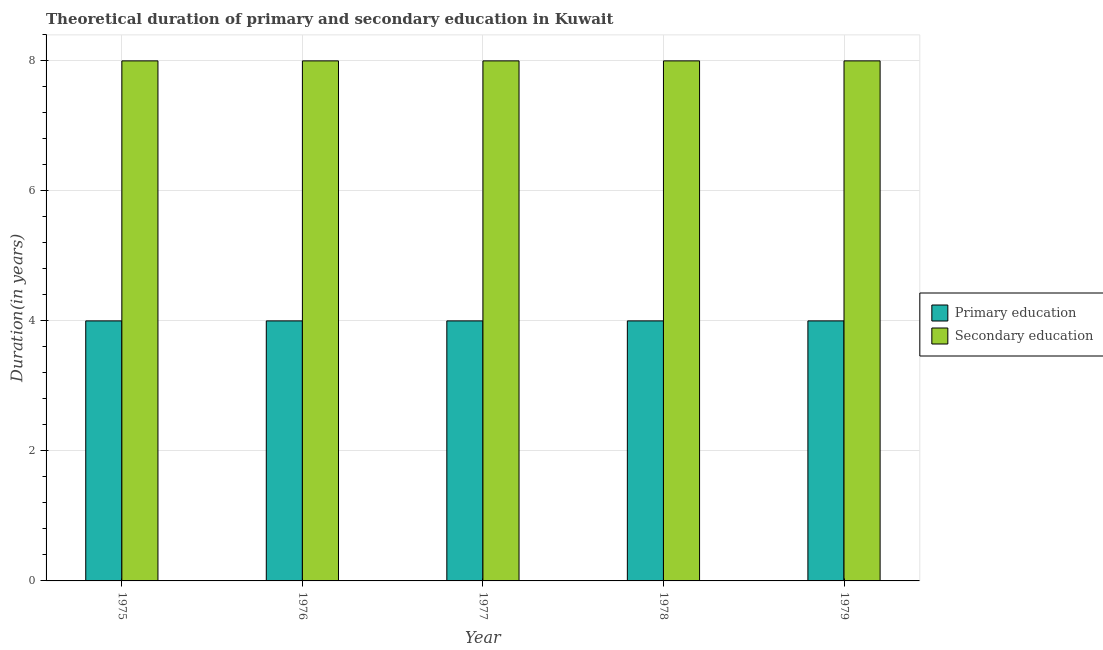How many different coloured bars are there?
Keep it short and to the point. 2. How many groups of bars are there?
Your answer should be very brief. 5. Are the number of bars per tick equal to the number of legend labels?
Your answer should be compact. Yes. Are the number of bars on each tick of the X-axis equal?
Your answer should be compact. Yes. How many bars are there on the 3rd tick from the left?
Your answer should be compact. 2. What is the label of the 4th group of bars from the left?
Your answer should be compact. 1978. In how many cases, is the number of bars for a given year not equal to the number of legend labels?
Give a very brief answer. 0. What is the duration of secondary education in 1975?
Your answer should be very brief. 8. Across all years, what is the maximum duration of primary education?
Ensure brevity in your answer.  4. Across all years, what is the minimum duration of secondary education?
Keep it short and to the point. 8. In which year was the duration of secondary education maximum?
Offer a very short reply. 1975. In which year was the duration of secondary education minimum?
Keep it short and to the point. 1975. What is the total duration of secondary education in the graph?
Ensure brevity in your answer.  40. Is the duration of secondary education in 1978 less than that in 1979?
Provide a short and direct response. No. What is the difference between the highest and the second highest duration of secondary education?
Offer a very short reply. 0. What is the difference between the highest and the lowest duration of primary education?
Your answer should be compact. 0. What does the 2nd bar from the left in 1978 represents?
Provide a succinct answer. Secondary education. What does the 1st bar from the right in 1979 represents?
Provide a succinct answer. Secondary education. How many bars are there?
Give a very brief answer. 10. Are all the bars in the graph horizontal?
Your response must be concise. No. How many years are there in the graph?
Your answer should be very brief. 5. Are the values on the major ticks of Y-axis written in scientific E-notation?
Your answer should be very brief. No. Does the graph contain any zero values?
Give a very brief answer. No. Does the graph contain grids?
Offer a very short reply. Yes. Where does the legend appear in the graph?
Your answer should be compact. Center right. What is the title of the graph?
Offer a terse response. Theoretical duration of primary and secondary education in Kuwait. Does "Non-pregnant women" appear as one of the legend labels in the graph?
Keep it short and to the point. No. What is the label or title of the Y-axis?
Make the answer very short. Duration(in years). What is the Duration(in years) in Primary education in 1975?
Make the answer very short. 4. What is the Duration(in years) of Secondary education in 1975?
Offer a terse response. 8. What is the Duration(in years) of Secondary education in 1977?
Your answer should be compact. 8. What is the Duration(in years) in Secondary education in 1978?
Offer a very short reply. 8. Across all years, what is the maximum Duration(in years) in Primary education?
Make the answer very short. 4. Across all years, what is the maximum Duration(in years) of Secondary education?
Make the answer very short. 8. What is the total Duration(in years) in Primary education in the graph?
Your answer should be compact. 20. What is the difference between the Duration(in years) in Secondary education in 1975 and that in 1976?
Ensure brevity in your answer.  0. What is the difference between the Duration(in years) in Primary education in 1975 and that in 1979?
Offer a terse response. 0. What is the difference between the Duration(in years) in Secondary education in 1975 and that in 1979?
Provide a succinct answer. 0. What is the difference between the Duration(in years) in Primary education in 1976 and that in 1978?
Make the answer very short. 0. What is the difference between the Duration(in years) in Primary education in 1976 and that in 1979?
Provide a succinct answer. 0. What is the difference between the Duration(in years) of Secondary education in 1976 and that in 1979?
Your answer should be very brief. 0. What is the difference between the Duration(in years) in Primary education in 1977 and that in 1978?
Ensure brevity in your answer.  0. What is the difference between the Duration(in years) of Secondary education in 1977 and that in 1978?
Give a very brief answer. 0. What is the difference between the Duration(in years) of Primary education in 1977 and that in 1979?
Keep it short and to the point. 0. What is the difference between the Duration(in years) of Secondary education in 1977 and that in 1979?
Offer a terse response. 0. What is the difference between the Duration(in years) of Primary education in 1978 and that in 1979?
Give a very brief answer. 0. What is the difference between the Duration(in years) of Secondary education in 1978 and that in 1979?
Provide a succinct answer. 0. What is the difference between the Duration(in years) of Primary education in 1975 and the Duration(in years) of Secondary education in 1978?
Ensure brevity in your answer.  -4. What is the difference between the Duration(in years) of Primary education in 1976 and the Duration(in years) of Secondary education in 1977?
Give a very brief answer. -4. What is the difference between the Duration(in years) of Primary education in 1976 and the Duration(in years) of Secondary education in 1978?
Provide a succinct answer. -4. What is the difference between the Duration(in years) of Primary education in 1978 and the Duration(in years) of Secondary education in 1979?
Your answer should be very brief. -4. In the year 1975, what is the difference between the Duration(in years) in Primary education and Duration(in years) in Secondary education?
Provide a short and direct response. -4. In the year 1976, what is the difference between the Duration(in years) in Primary education and Duration(in years) in Secondary education?
Provide a short and direct response. -4. In the year 1977, what is the difference between the Duration(in years) in Primary education and Duration(in years) in Secondary education?
Give a very brief answer. -4. In the year 1979, what is the difference between the Duration(in years) of Primary education and Duration(in years) of Secondary education?
Provide a short and direct response. -4. What is the ratio of the Duration(in years) in Secondary education in 1975 to that in 1976?
Provide a succinct answer. 1. What is the ratio of the Duration(in years) in Primary education in 1975 to that in 1977?
Ensure brevity in your answer.  1. What is the ratio of the Duration(in years) of Primary education in 1975 to that in 1978?
Your answer should be very brief. 1. What is the ratio of the Duration(in years) of Secondary education in 1975 to that in 1978?
Your answer should be very brief. 1. What is the ratio of the Duration(in years) of Primary education in 1975 to that in 1979?
Your response must be concise. 1. What is the ratio of the Duration(in years) of Secondary education in 1975 to that in 1979?
Ensure brevity in your answer.  1. What is the ratio of the Duration(in years) in Primary education in 1976 to that in 1977?
Offer a very short reply. 1. What is the ratio of the Duration(in years) of Secondary education in 1976 to that in 1978?
Your answer should be compact. 1. What is the ratio of the Duration(in years) of Primary education in 1977 to that in 1979?
Provide a succinct answer. 1. What is the ratio of the Duration(in years) of Secondary education in 1977 to that in 1979?
Your answer should be very brief. 1. What is the ratio of the Duration(in years) of Secondary education in 1978 to that in 1979?
Provide a short and direct response. 1. 